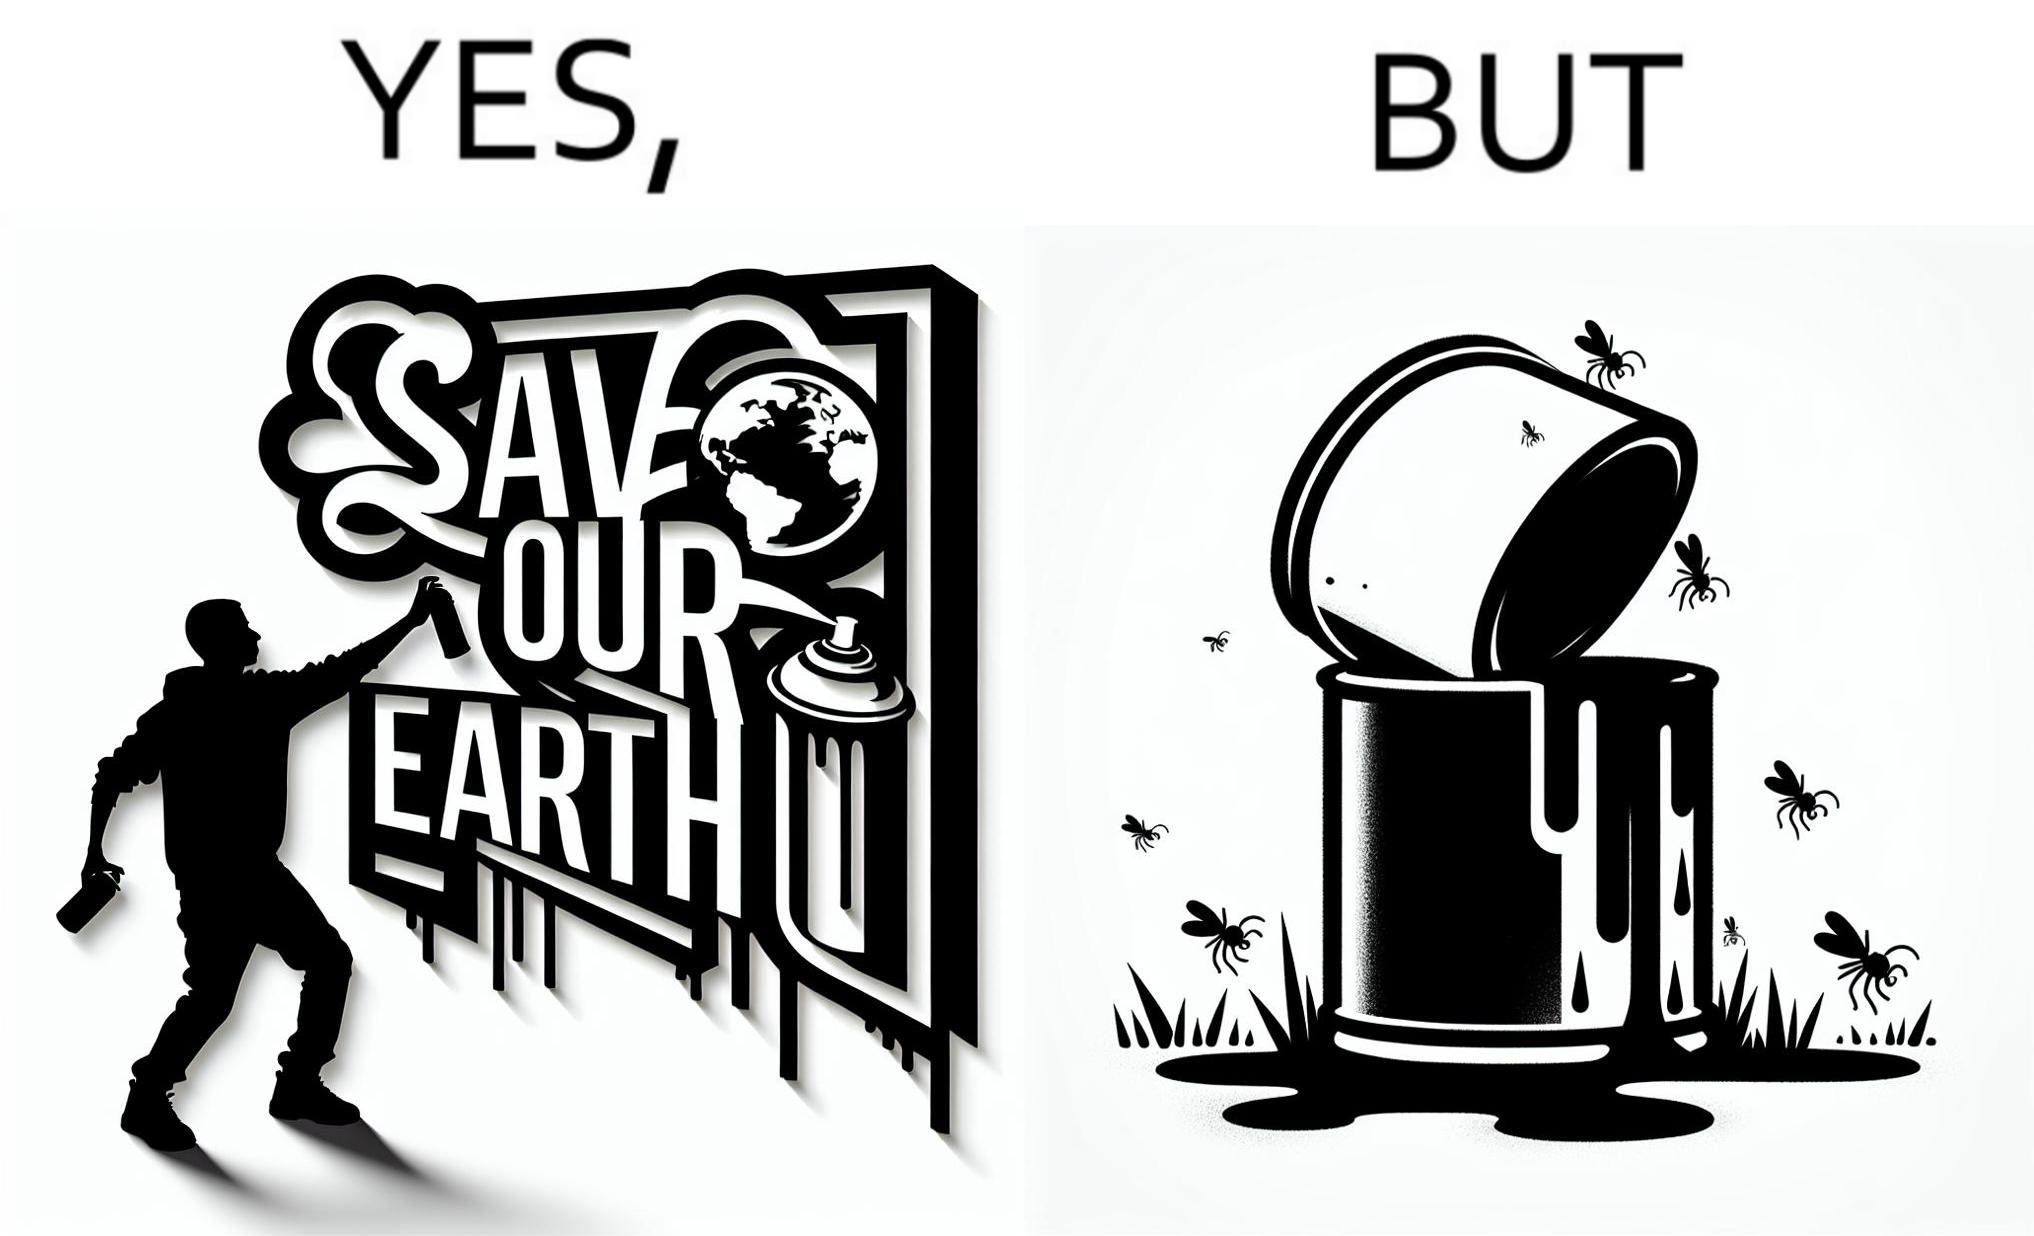What is the satirical meaning behind this image? The image is ironical, as the cans of paint used to make graffiti on the theme "Save the Earth" seems to be destroying the Earth when it overflows on the grass, as it is harmful for the flora and fauna, as can be seen from the dying insects. 